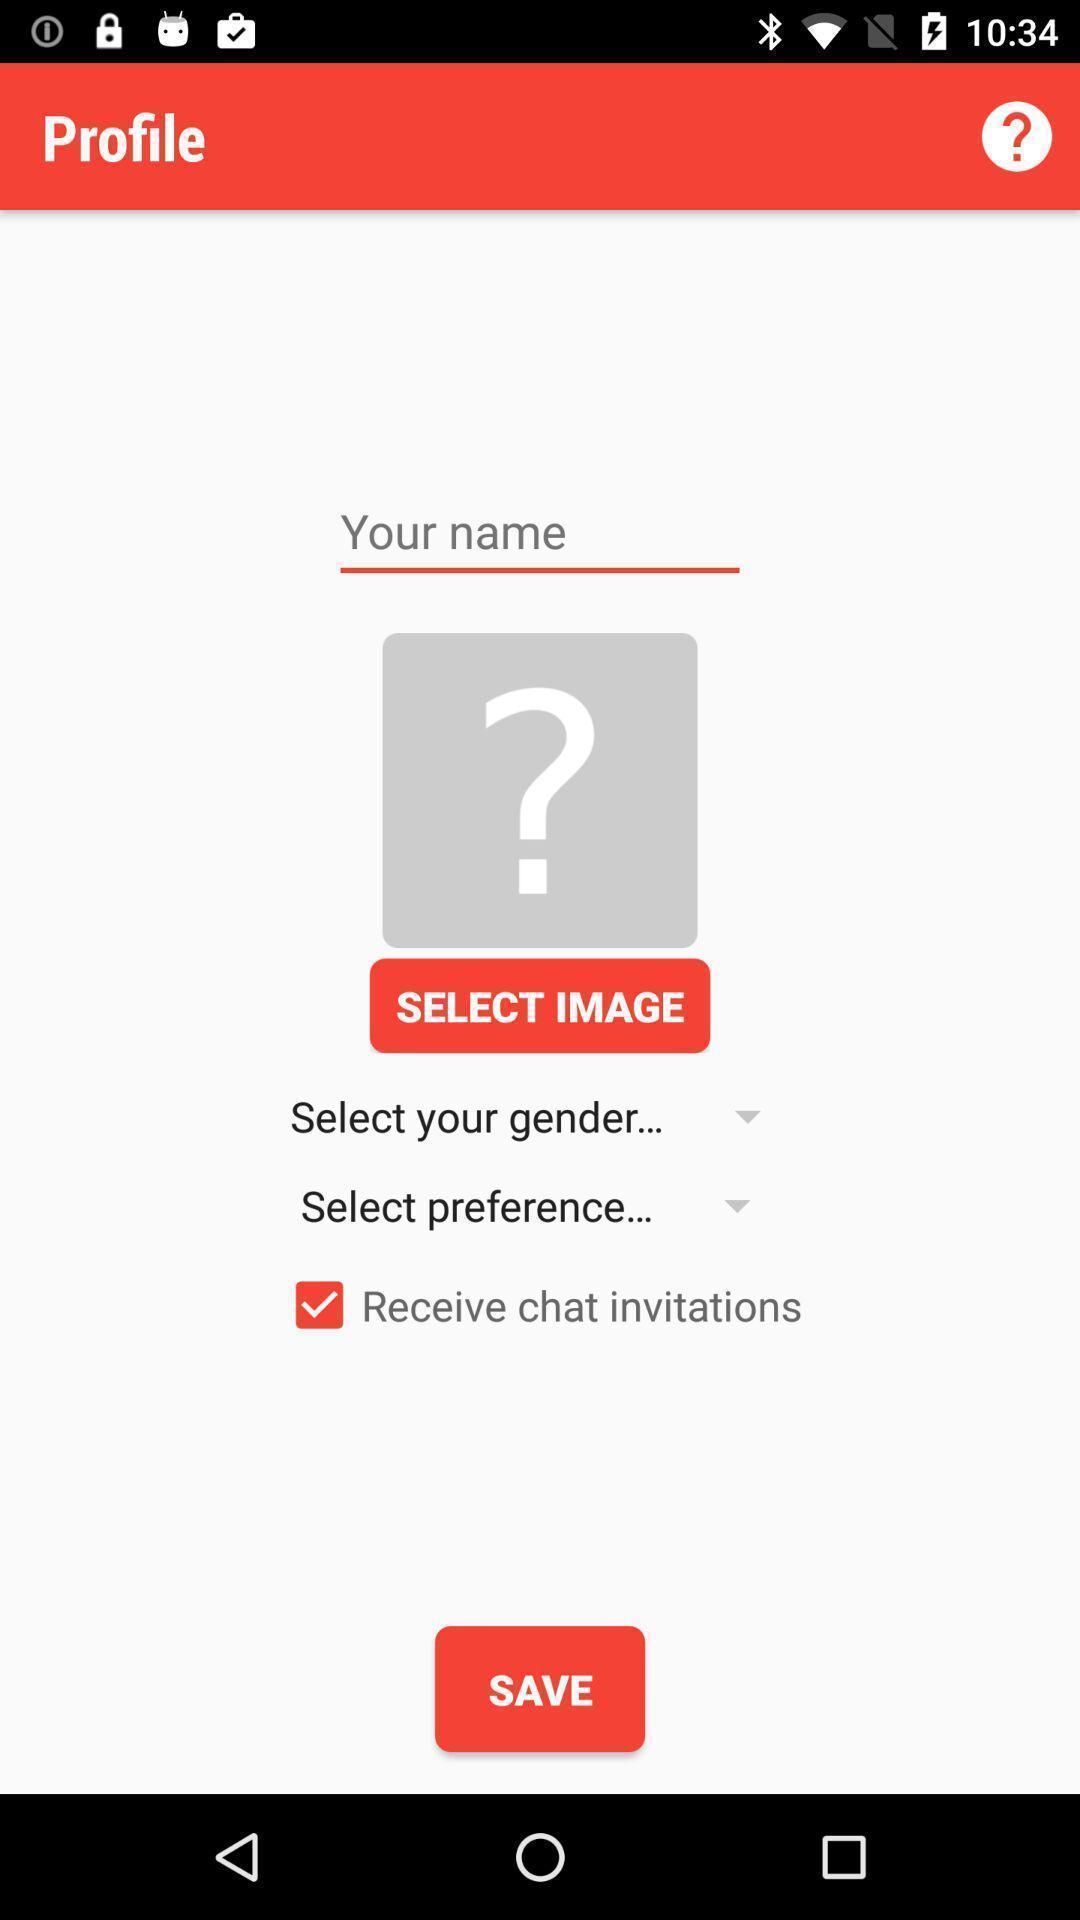Please provide a description for this image. Profile page showing edit options. 